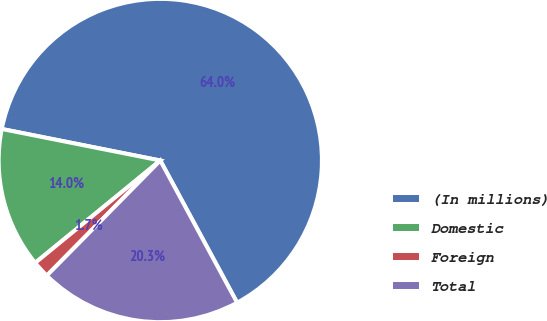<chart> <loc_0><loc_0><loc_500><loc_500><pie_chart><fcel>(In millions)<fcel>Domestic<fcel>Foreign<fcel>Total<nl><fcel>63.99%<fcel>14.04%<fcel>1.7%<fcel>20.27%<nl></chart> 